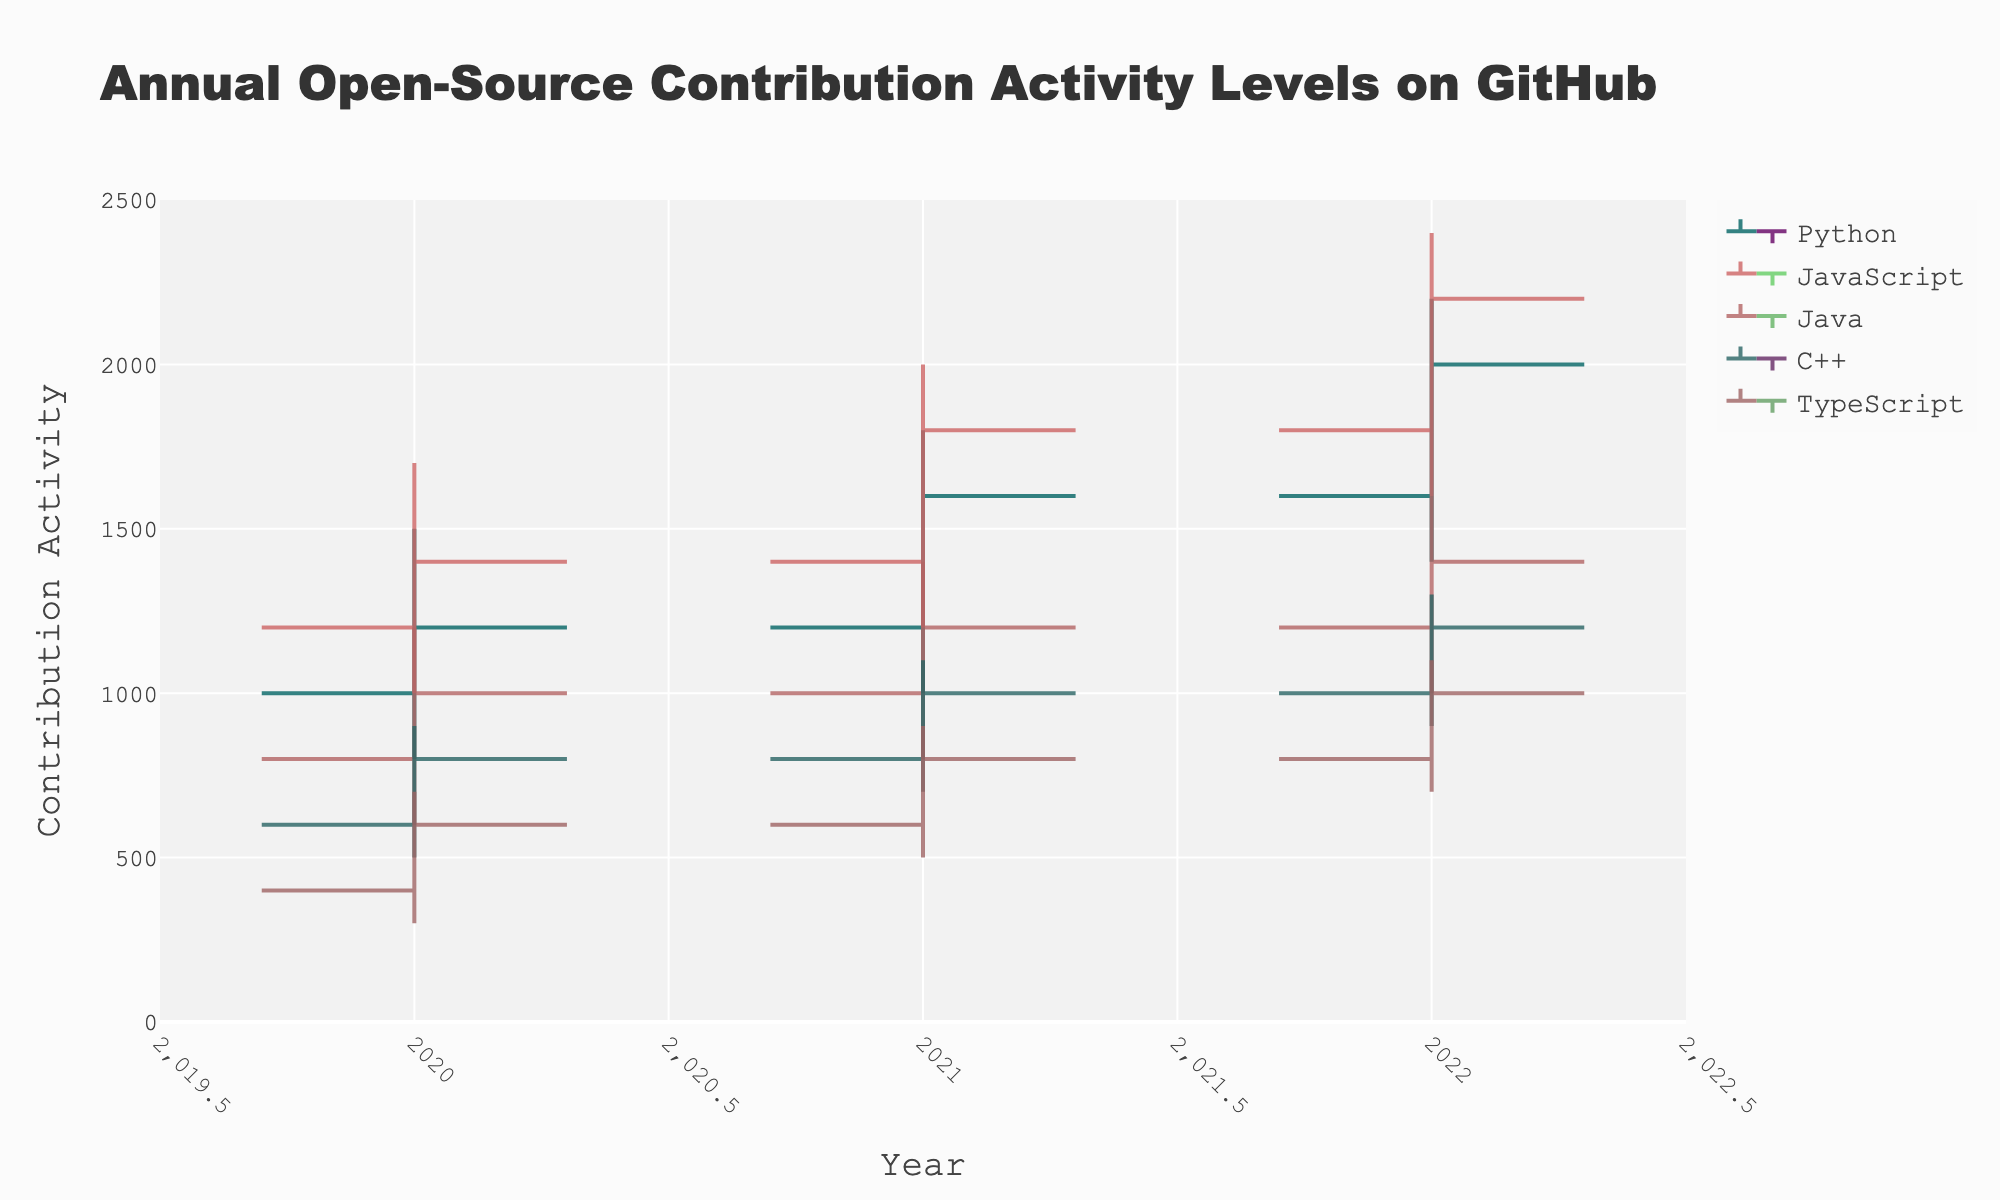What's the title of the plot? The title is displayed prominently at the top of the figure. It reads 'Annual Open-Source Contribution Activity Levels on GitHub'.
Answer: Annual Open-Source Contribution Activity Levels on GitHub What are the x and y-axis titles? The x-axis title is located below the horizontal axis and reads 'Year'. The y-axis title is located beside the vertical axis and reads 'Contribution Activity'.
Answer: x-axis: Year, y-axis: Contribution Activity Which language had the highest high value in 2022? We need to look at the highest values for each language in the year 2022. JavaScript had the highest value at 2400 in 2022.
Answer: JavaScript How did Python's contribution activity close value change from 2020 to 2021? We compare the close values for Python in 2020 (1200) and 2021 (1600). The difference is 1600 - 1200 = 400.
Answer: Increased by 400 Which language showed the least volatility in 2020? Volatility can be assessed by the range (High - Low). We calculate the range for each language in 2020: Python (1500-800=700), JavaScript (1700-1000=700), Java (1200-600=600), C++ (900-500=400), TypeScript (700-300=400). Both C++ and TypeScript have the least range at 400.
Answer: C++ and TypeScript What trend do you notice in TypeScript's open-source contributions from 2020 to 2022? Observing the open values over the years for TypeScript, we can see an upward trend: 2020 (400), 2021 (600), 2022 (800).
Answer: Increasing trend Which year saw the highest close value for Java? We look at the close values for Java across all years: 2020 (1000), 2021 (1200), 2022 (1400). The highest close value is in 2022.
Answer: 2022 Did any language have decreasing closing contributions every year? We check the close values for each language across the three years. None of the languages show a consistent decrease in their closing values from 2020 to 2022.
Answer: No What was the total high value for all languages combined in 2021? We sum the high values of all languages for 2021: Python (1800), JavaScript (2000), Java (1400), C++ (1100), TypeScript (900). The total is 1800 + 2000 + 1400 + 1100 + 900 = 7200.
Answer: 7200 